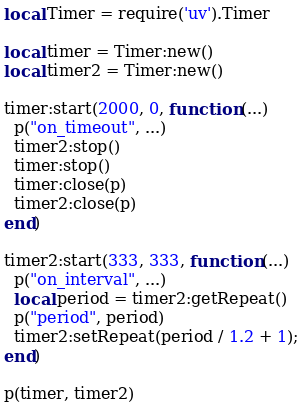Convert code to text. <code><loc_0><loc_0><loc_500><loc_500><_Lua_>local Timer = require('uv').Timer

local timer = Timer:new()
local timer2 = Timer:new()

timer:start(2000, 0, function (...)
  p("on_timeout", ...)
  timer2:stop()
  timer:stop()
  timer:close(p)
  timer2:close(p)
end)

timer2:start(333, 333, function (...)
  p("on_interval", ...)
  local period = timer2:getRepeat()
  p("period", period)
  timer2:setRepeat(period / 1.2 + 1);
end)

p(timer, timer2)
</code> 